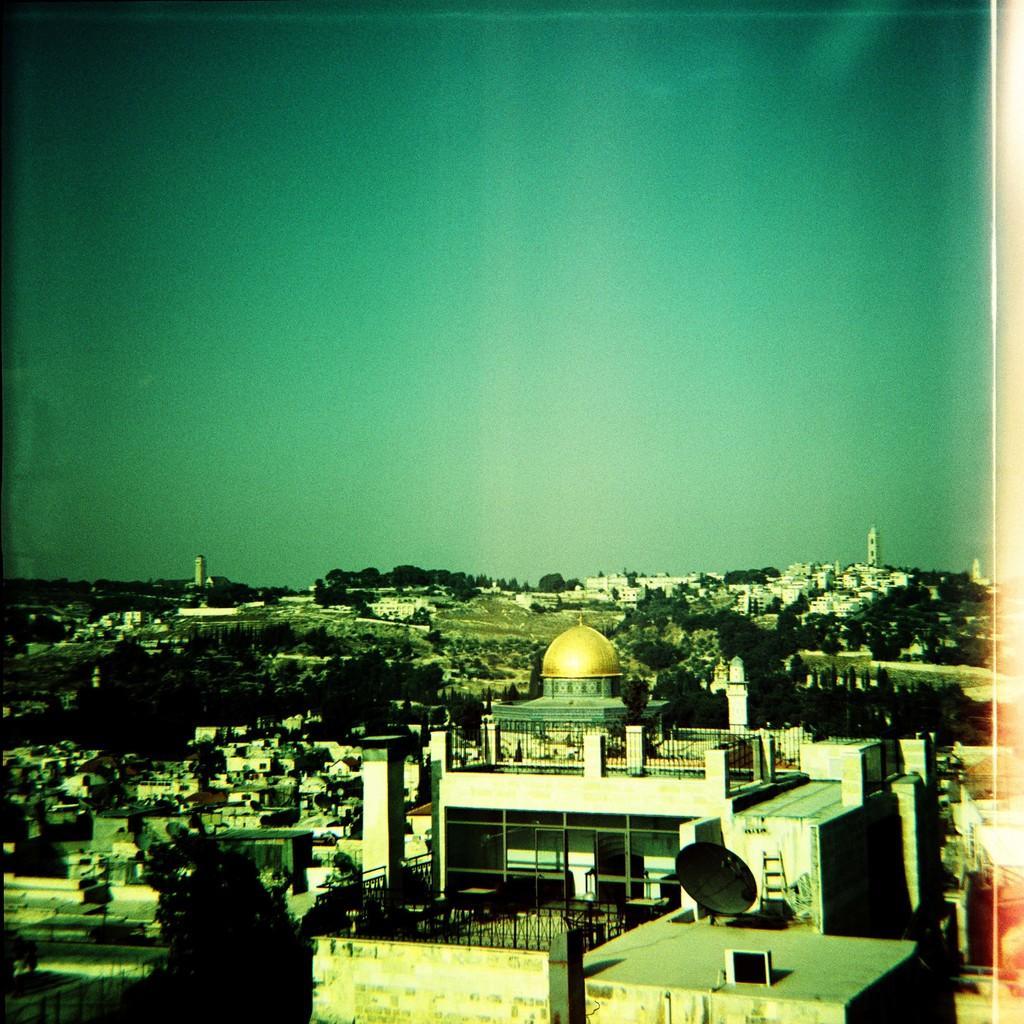Please provide a concise description of this image. In this image at the bottom there are some buildings, trees, houses and at the top of the image there is sky and also i can see some towers and poles. 